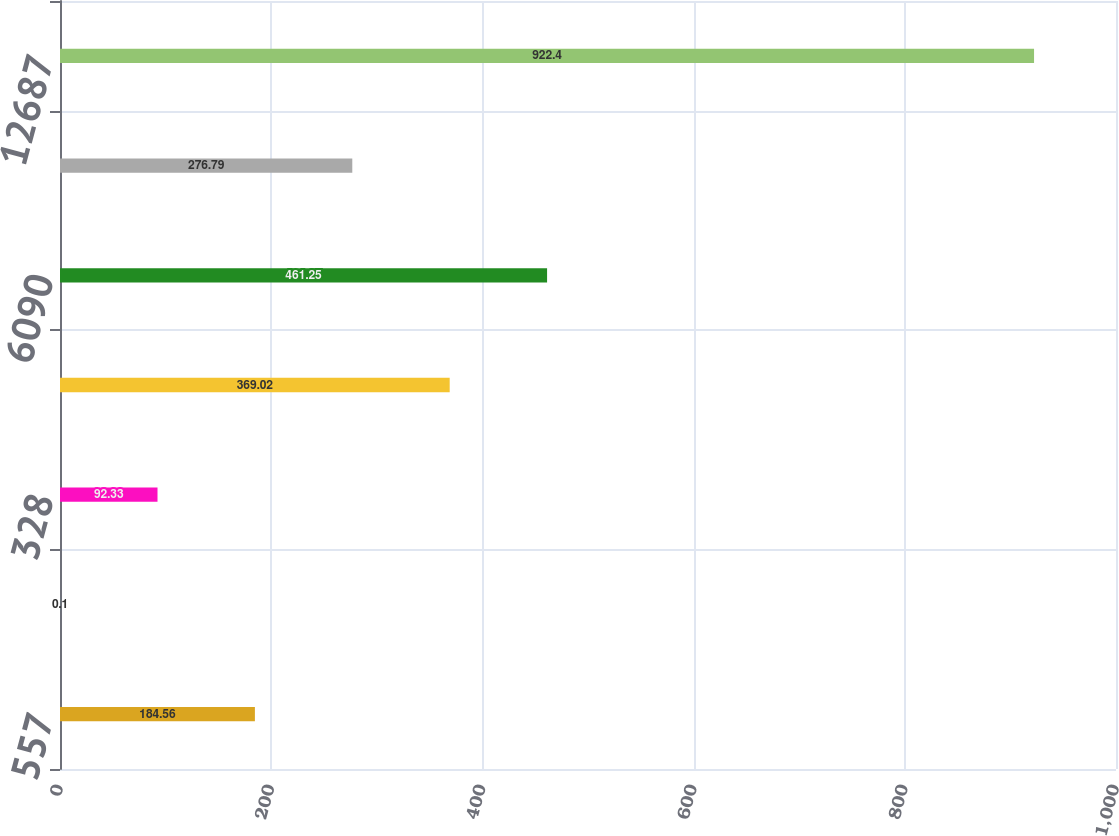Convert chart. <chart><loc_0><loc_0><loc_500><loc_500><bar_chart><fcel>557<fcel>127<fcel>328<fcel>4413<fcel>6090<fcel>1138<fcel>12687<nl><fcel>184.56<fcel>0.1<fcel>92.33<fcel>369.02<fcel>461.25<fcel>276.79<fcel>922.4<nl></chart> 